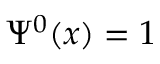Convert formula to latex. <formula><loc_0><loc_0><loc_500><loc_500>\Psi ^ { 0 } ( x ) = 1</formula> 